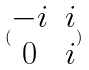<formula> <loc_0><loc_0><loc_500><loc_500>( \begin{matrix} - i & i \\ 0 & i \end{matrix} )</formula> 